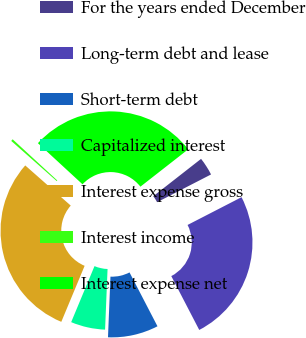Convert chart. <chart><loc_0><loc_0><loc_500><loc_500><pie_chart><fcel>For the years ended December<fcel>Long-term debt and lease<fcel>Short-term debt<fcel>Capitalized interest<fcel>Interest expense gross<fcel>Interest income<fcel>Interest expense net<nl><fcel>2.99%<fcel>24.95%<fcel>8.27%<fcel>5.63%<fcel>30.23%<fcel>0.35%<fcel>27.59%<nl></chart> 